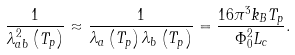<formula> <loc_0><loc_0><loc_500><loc_500>\frac { 1 } { \lambda _ { a b } ^ { 2 } \left ( T _ { p } \right ) } \approx \frac { 1 } { \lambda _ { a } \left ( T _ { p } \right ) \lambda _ { b } \left ( T _ { p } \right ) } = \frac { 1 6 \pi ^ { 3 } k _ { B } T _ { p } } { \Phi _ { 0 } ^ { 2 } L _ { c } } .</formula> 